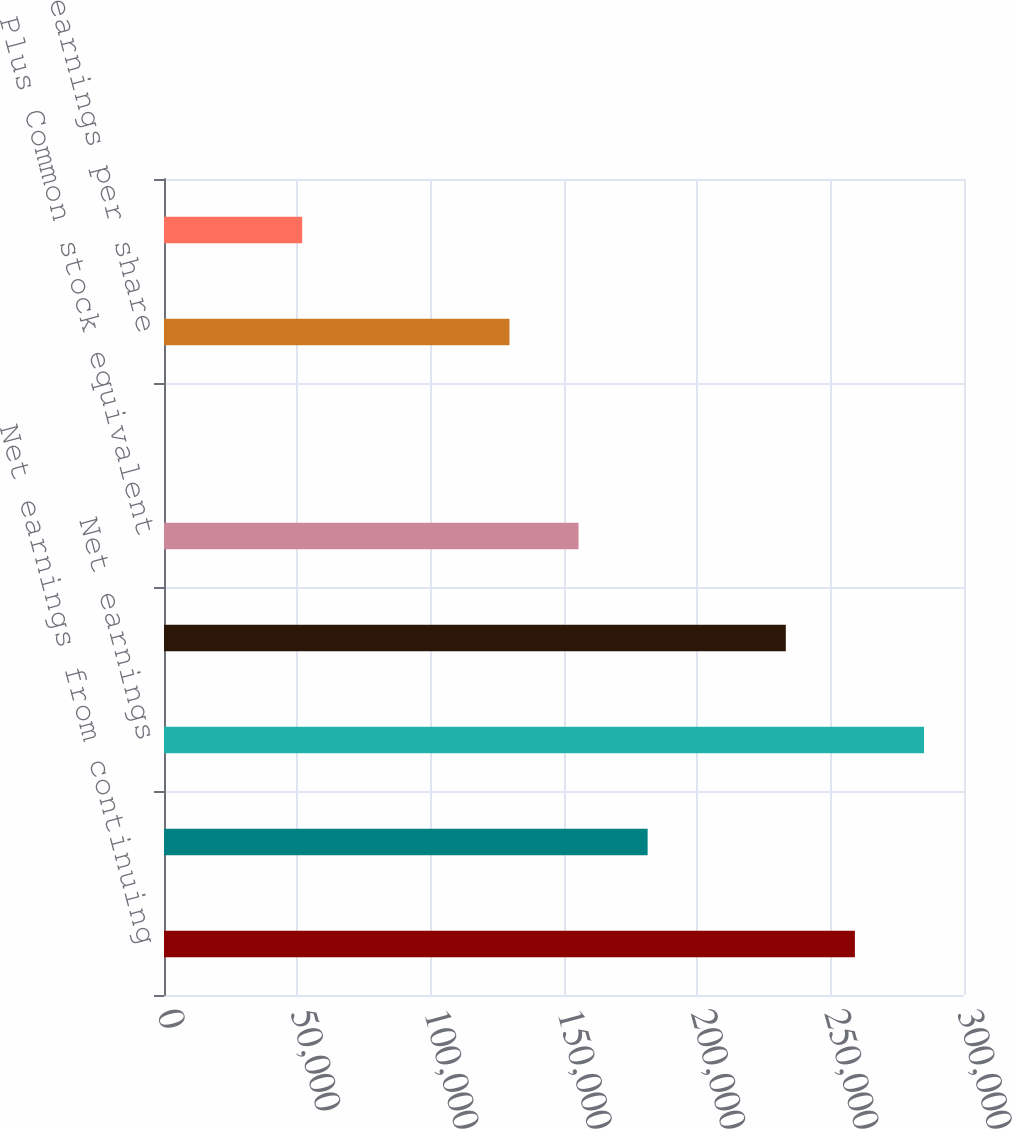<chart> <loc_0><loc_0><loc_500><loc_500><bar_chart><fcel>Net earnings from continuing<fcel>Net earnings from discontinued<fcel>Net earnings<fcel>Weighted average shares<fcel>Plus Common stock equivalent<fcel>Basic net earnings from<fcel>Basic net earnings per share<fcel>Diluted net earnings from<nl><fcel>259087<fcel>181361<fcel>284996<fcel>233178<fcel>155452<fcel>0.1<fcel>129544<fcel>51817.5<nl></chart> 